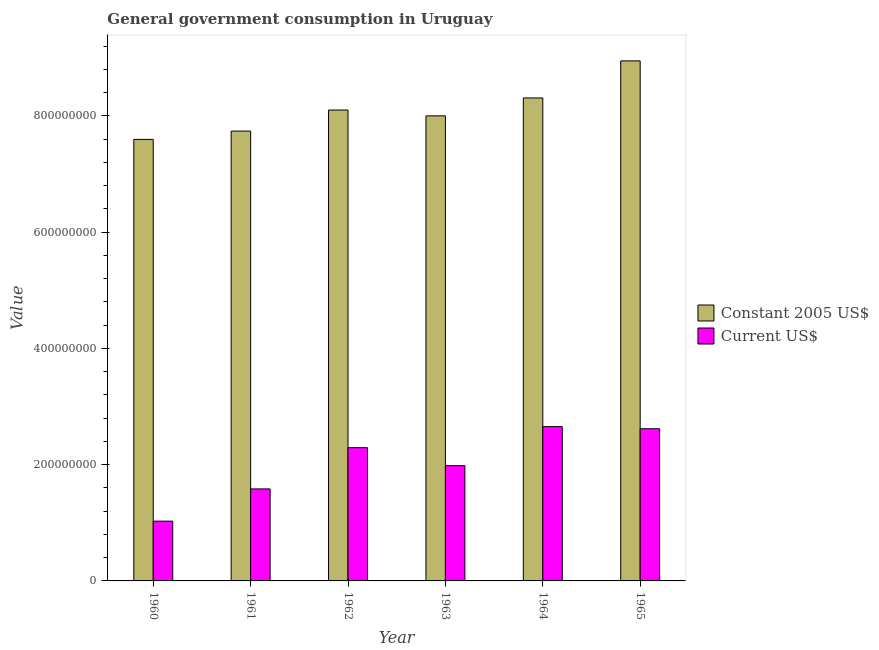How many different coloured bars are there?
Make the answer very short. 2. How many bars are there on the 4th tick from the left?
Offer a terse response. 2. What is the value consumed in constant 2005 us$ in 1961?
Provide a short and direct response. 7.74e+08. Across all years, what is the maximum value consumed in current us$?
Keep it short and to the point. 2.65e+08. Across all years, what is the minimum value consumed in current us$?
Give a very brief answer. 1.03e+08. In which year was the value consumed in constant 2005 us$ maximum?
Your response must be concise. 1965. What is the total value consumed in current us$ in the graph?
Give a very brief answer. 1.22e+09. What is the difference between the value consumed in constant 2005 us$ in 1962 and that in 1963?
Offer a very short reply. 1.00e+07. What is the difference between the value consumed in constant 2005 us$ in 1963 and the value consumed in current us$ in 1964?
Provide a succinct answer. -3.08e+07. What is the average value consumed in current us$ per year?
Offer a terse response. 2.03e+08. In the year 1960, what is the difference between the value consumed in constant 2005 us$ and value consumed in current us$?
Your response must be concise. 0. What is the ratio of the value consumed in current us$ in 1960 to that in 1961?
Your response must be concise. 0.65. Is the value consumed in current us$ in 1963 less than that in 1965?
Make the answer very short. Yes. What is the difference between the highest and the second highest value consumed in current us$?
Offer a terse response. 3.65e+06. What is the difference between the highest and the lowest value consumed in current us$?
Your answer should be very brief. 1.63e+08. In how many years, is the value consumed in current us$ greater than the average value consumed in current us$ taken over all years?
Your answer should be very brief. 3. What does the 2nd bar from the left in 1960 represents?
Ensure brevity in your answer.  Current US$. What does the 2nd bar from the right in 1965 represents?
Keep it short and to the point. Constant 2005 US$. How many bars are there?
Offer a very short reply. 12. How many years are there in the graph?
Keep it short and to the point. 6. How many legend labels are there?
Keep it short and to the point. 2. What is the title of the graph?
Offer a very short reply. General government consumption in Uruguay. Does "Females" appear as one of the legend labels in the graph?
Provide a short and direct response. No. What is the label or title of the Y-axis?
Ensure brevity in your answer.  Value. What is the Value of Constant 2005 US$ in 1960?
Your response must be concise. 7.59e+08. What is the Value of Current US$ in 1960?
Offer a terse response. 1.03e+08. What is the Value of Constant 2005 US$ in 1961?
Offer a very short reply. 7.74e+08. What is the Value of Current US$ in 1961?
Offer a very short reply. 1.58e+08. What is the Value of Constant 2005 US$ in 1962?
Offer a terse response. 8.10e+08. What is the Value in Current US$ in 1962?
Your answer should be very brief. 2.29e+08. What is the Value of Constant 2005 US$ in 1963?
Offer a terse response. 8.00e+08. What is the Value of Current US$ in 1963?
Your response must be concise. 1.98e+08. What is the Value in Constant 2005 US$ in 1964?
Provide a succinct answer. 8.31e+08. What is the Value of Current US$ in 1964?
Ensure brevity in your answer.  2.65e+08. What is the Value of Constant 2005 US$ in 1965?
Keep it short and to the point. 8.94e+08. What is the Value in Current US$ in 1965?
Keep it short and to the point. 2.62e+08. Across all years, what is the maximum Value in Constant 2005 US$?
Your answer should be compact. 8.94e+08. Across all years, what is the maximum Value in Current US$?
Your answer should be compact. 2.65e+08. Across all years, what is the minimum Value of Constant 2005 US$?
Your answer should be compact. 7.59e+08. Across all years, what is the minimum Value of Current US$?
Keep it short and to the point. 1.03e+08. What is the total Value in Constant 2005 US$ in the graph?
Ensure brevity in your answer.  4.87e+09. What is the total Value of Current US$ in the graph?
Offer a terse response. 1.22e+09. What is the difference between the Value of Constant 2005 US$ in 1960 and that in 1961?
Offer a terse response. -1.43e+07. What is the difference between the Value of Current US$ in 1960 and that in 1961?
Make the answer very short. -5.54e+07. What is the difference between the Value of Constant 2005 US$ in 1960 and that in 1962?
Offer a very short reply. -5.05e+07. What is the difference between the Value in Current US$ in 1960 and that in 1962?
Give a very brief answer. -1.26e+08. What is the difference between the Value of Constant 2005 US$ in 1960 and that in 1963?
Your answer should be compact. -4.05e+07. What is the difference between the Value of Current US$ in 1960 and that in 1963?
Give a very brief answer. -9.54e+07. What is the difference between the Value in Constant 2005 US$ in 1960 and that in 1964?
Make the answer very short. -7.13e+07. What is the difference between the Value of Current US$ in 1960 and that in 1964?
Keep it short and to the point. -1.63e+08. What is the difference between the Value of Constant 2005 US$ in 1960 and that in 1965?
Keep it short and to the point. -1.35e+08. What is the difference between the Value in Current US$ in 1960 and that in 1965?
Your answer should be compact. -1.59e+08. What is the difference between the Value in Constant 2005 US$ in 1961 and that in 1962?
Your answer should be compact. -3.62e+07. What is the difference between the Value in Current US$ in 1961 and that in 1962?
Ensure brevity in your answer.  -7.09e+07. What is the difference between the Value of Constant 2005 US$ in 1961 and that in 1963?
Make the answer very short. -2.61e+07. What is the difference between the Value in Current US$ in 1961 and that in 1963?
Give a very brief answer. -4.00e+07. What is the difference between the Value of Constant 2005 US$ in 1961 and that in 1964?
Provide a succinct answer. -5.70e+07. What is the difference between the Value of Current US$ in 1961 and that in 1964?
Make the answer very short. -1.07e+08. What is the difference between the Value of Constant 2005 US$ in 1961 and that in 1965?
Your answer should be compact. -1.21e+08. What is the difference between the Value in Current US$ in 1961 and that in 1965?
Provide a succinct answer. -1.03e+08. What is the difference between the Value in Constant 2005 US$ in 1962 and that in 1963?
Give a very brief answer. 1.00e+07. What is the difference between the Value in Current US$ in 1962 and that in 1963?
Your answer should be very brief. 3.09e+07. What is the difference between the Value in Constant 2005 US$ in 1962 and that in 1964?
Provide a short and direct response. -2.08e+07. What is the difference between the Value of Current US$ in 1962 and that in 1964?
Your answer should be very brief. -3.62e+07. What is the difference between the Value in Constant 2005 US$ in 1962 and that in 1965?
Your answer should be compact. -8.45e+07. What is the difference between the Value in Current US$ in 1962 and that in 1965?
Your response must be concise. -3.26e+07. What is the difference between the Value in Constant 2005 US$ in 1963 and that in 1964?
Your response must be concise. -3.08e+07. What is the difference between the Value in Current US$ in 1963 and that in 1964?
Offer a terse response. -6.72e+07. What is the difference between the Value of Constant 2005 US$ in 1963 and that in 1965?
Give a very brief answer. -9.46e+07. What is the difference between the Value in Current US$ in 1963 and that in 1965?
Make the answer very short. -6.35e+07. What is the difference between the Value of Constant 2005 US$ in 1964 and that in 1965?
Your answer should be compact. -6.38e+07. What is the difference between the Value in Current US$ in 1964 and that in 1965?
Offer a terse response. 3.65e+06. What is the difference between the Value of Constant 2005 US$ in 1960 and the Value of Current US$ in 1961?
Provide a succinct answer. 6.01e+08. What is the difference between the Value of Constant 2005 US$ in 1960 and the Value of Current US$ in 1962?
Your answer should be compact. 5.30e+08. What is the difference between the Value of Constant 2005 US$ in 1960 and the Value of Current US$ in 1963?
Make the answer very short. 5.61e+08. What is the difference between the Value of Constant 2005 US$ in 1960 and the Value of Current US$ in 1964?
Your response must be concise. 4.94e+08. What is the difference between the Value of Constant 2005 US$ in 1960 and the Value of Current US$ in 1965?
Provide a short and direct response. 4.98e+08. What is the difference between the Value of Constant 2005 US$ in 1961 and the Value of Current US$ in 1962?
Keep it short and to the point. 5.45e+08. What is the difference between the Value of Constant 2005 US$ in 1961 and the Value of Current US$ in 1963?
Offer a very short reply. 5.76e+08. What is the difference between the Value of Constant 2005 US$ in 1961 and the Value of Current US$ in 1964?
Make the answer very short. 5.08e+08. What is the difference between the Value in Constant 2005 US$ in 1961 and the Value in Current US$ in 1965?
Make the answer very short. 5.12e+08. What is the difference between the Value of Constant 2005 US$ in 1962 and the Value of Current US$ in 1963?
Offer a very short reply. 6.12e+08. What is the difference between the Value of Constant 2005 US$ in 1962 and the Value of Current US$ in 1964?
Give a very brief answer. 5.45e+08. What is the difference between the Value in Constant 2005 US$ in 1962 and the Value in Current US$ in 1965?
Your response must be concise. 5.48e+08. What is the difference between the Value of Constant 2005 US$ in 1963 and the Value of Current US$ in 1964?
Offer a terse response. 5.35e+08. What is the difference between the Value of Constant 2005 US$ in 1963 and the Value of Current US$ in 1965?
Ensure brevity in your answer.  5.38e+08. What is the difference between the Value in Constant 2005 US$ in 1964 and the Value in Current US$ in 1965?
Your response must be concise. 5.69e+08. What is the average Value of Constant 2005 US$ per year?
Offer a very short reply. 8.11e+08. What is the average Value in Current US$ per year?
Keep it short and to the point. 2.03e+08. In the year 1960, what is the difference between the Value of Constant 2005 US$ and Value of Current US$?
Your response must be concise. 6.57e+08. In the year 1961, what is the difference between the Value in Constant 2005 US$ and Value in Current US$?
Give a very brief answer. 6.16e+08. In the year 1962, what is the difference between the Value of Constant 2005 US$ and Value of Current US$?
Keep it short and to the point. 5.81e+08. In the year 1963, what is the difference between the Value in Constant 2005 US$ and Value in Current US$?
Make the answer very short. 6.02e+08. In the year 1964, what is the difference between the Value in Constant 2005 US$ and Value in Current US$?
Offer a terse response. 5.65e+08. In the year 1965, what is the difference between the Value in Constant 2005 US$ and Value in Current US$?
Ensure brevity in your answer.  6.33e+08. What is the ratio of the Value in Constant 2005 US$ in 1960 to that in 1961?
Your answer should be very brief. 0.98. What is the ratio of the Value of Current US$ in 1960 to that in 1961?
Provide a short and direct response. 0.65. What is the ratio of the Value of Constant 2005 US$ in 1960 to that in 1962?
Your answer should be very brief. 0.94. What is the ratio of the Value of Current US$ in 1960 to that in 1962?
Ensure brevity in your answer.  0.45. What is the ratio of the Value of Constant 2005 US$ in 1960 to that in 1963?
Ensure brevity in your answer.  0.95. What is the ratio of the Value of Current US$ in 1960 to that in 1963?
Provide a short and direct response. 0.52. What is the ratio of the Value of Constant 2005 US$ in 1960 to that in 1964?
Give a very brief answer. 0.91. What is the ratio of the Value of Current US$ in 1960 to that in 1964?
Your response must be concise. 0.39. What is the ratio of the Value in Constant 2005 US$ in 1960 to that in 1965?
Provide a succinct answer. 0.85. What is the ratio of the Value in Current US$ in 1960 to that in 1965?
Ensure brevity in your answer.  0.39. What is the ratio of the Value in Constant 2005 US$ in 1961 to that in 1962?
Offer a terse response. 0.96. What is the ratio of the Value of Current US$ in 1961 to that in 1962?
Your answer should be very brief. 0.69. What is the ratio of the Value in Constant 2005 US$ in 1961 to that in 1963?
Keep it short and to the point. 0.97. What is the ratio of the Value of Current US$ in 1961 to that in 1963?
Provide a short and direct response. 0.8. What is the ratio of the Value in Constant 2005 US$ in 1961 to that in 1964?
Offer a very short reply. 0.93. What is the ratio of the Value of Current US$ in 1961 to that in 1964?
Offer a terse response. 0.6. What is the ratio of the Value of Constant 2005 US$ in 1961 to that in 1965?
Ensure brevity in your answer.  0.86. What is the ratio of the Value in Current US$ in 1961 to that in 1965?
Offer a very short reply. 0.6. What is the ratio of the Value of Constant 2005 US$ in 1962 to that in 1963?
Your response must be concise. 1.01. What is the ratio of the Value in Current US$ in 1962 to that in 1963?
Offer a very short reply. 1.16. What is the ratio of the Value in Constant 2005 US$ in 1962 to that in 1964?
Offer a terse response. 0.97. What is the ratio of the Value of Current US$ in 1962 to that in 1964?
Make the answer very short. 0.86. What is the ratio of the Value of Constant 2005 US$ in 1962 to that in 1965?
Your answer should be very brief. 0.91. What is the ratio of the Value of Current US$ in 1962 to that in 1965?
Make the answer very short. 0.88. What is the ratio of the Value in Constant 2005 US$ in 1963 to that in 1964?
Give a very brief answer. 0.96. What is the ratio of the Value of Current US$ in 1963 to that in 1964?
Make the answer very short. 0.75. What is the ratio of the Value of Constant 2005 US$ in 1963 to that in 1965?
Your response must be concise. 0.89. What is the ratio of the Value in Current US$ in 1963 to that in 1965?
Your answer should be very brief. 0.76. What is the ratio of the Value in Constant 2005 US$ in 1964 to that in 1965?
Offer a terse response. 0.93. What is the ratio of the Value of Current US$ in 1964 to that in 1965?
Offer a terse response. 1.01. What is the difference between the highest and the second highest Value of Constant 2005 US$?
Keep it short and to the point. 6.38e+07. What is the difference between the highest and the second highest Value of Current US$?
Give a very brief answer. 3.65e+06. What is the difference between the highest and the lowest Value of Constant 2005 US$?
Your response must be concise. 1.35e+08. What is the difference between the highest and the lowest Value of Current US$?
Make the answer very short. 1.63e+08. 